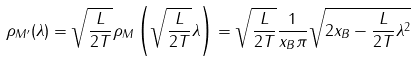Convert formula to latex. <formula><loc_0><loc_0><loc_500><loc_500>\rho _ { M ^ { \prime } } ( \lambda ) = \sqrt { \frac { L } { 2 T } } \rho _ { M } \left ( \sqrt { \frac { L } { 2 T } } \lambda \right ) = \sqrt { \frac { L } { 2 T } } \frac { 1 } { x _ { B } \pi } \sqrt { 2 x _ { B } - \frac { L } { 2 T } \lambda ^ { 2 } }</formula> 